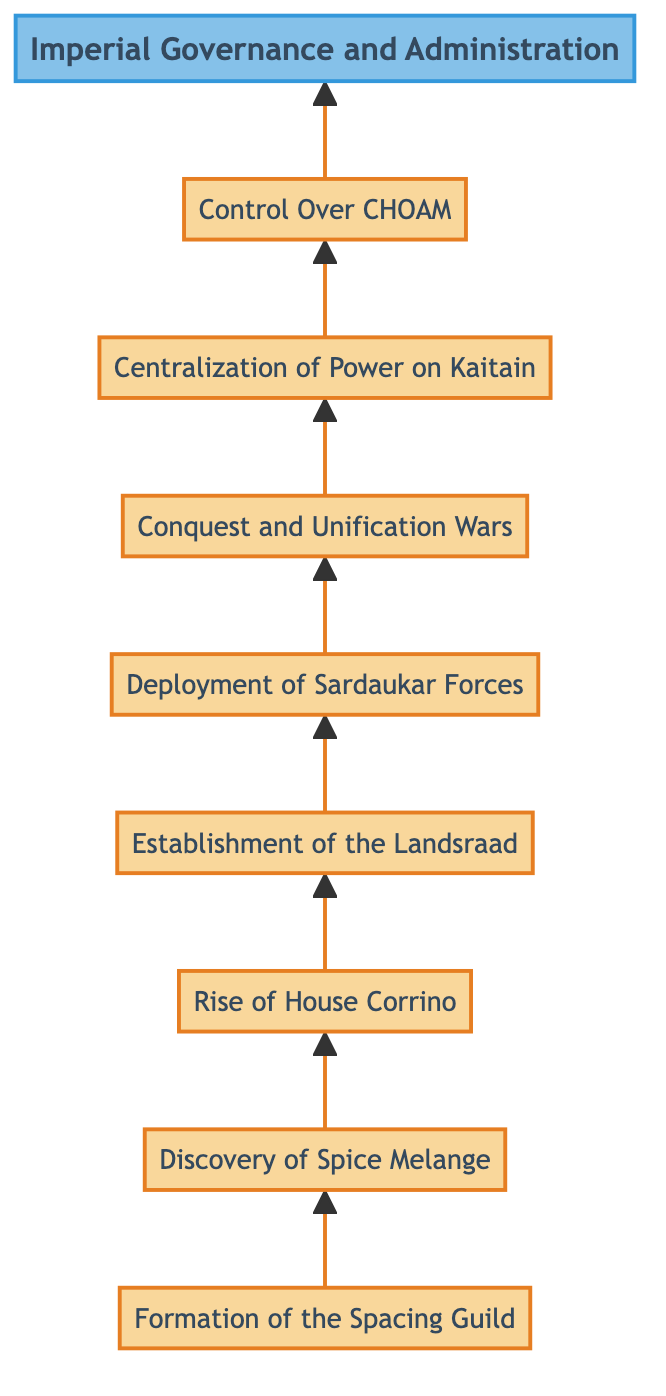What is the topmost node in the diagram? The topmost node in the diagram is "Imperial Governance and Administration," as it is the final point in the flowchart and is positioned at the top.
Answer: Imperial Governance and Administration How many nodes are present in the diagram? There are a total of nine nodes represented in the diagram, each corresponding to a significant event in the rise of the Galactic Empire.
Answer: 9 Which node follows the "Deployment of Sardaukar Forces"? The node that directly follows "Deployment of Sardaukar Forces" is "Conquest and Unification Wars," indicating the action resulting from the deployment of these elite troops.
Answer: Conquest and Unification Wars What event directly led to the "Rise of House Corrino"? The event that directly led to the "Rise of House Corrino" is the "Discovery of Spice Melange," as control over this valuable resource played a crucial role in their ascendancy.
Answer: Discovery of Spice Melange What is the relationship between "Establishment of the Landsraad" and "Centralization of Power on Kaitain"? "Establishment of the Landsraad" is a preceding event that contributes to the "Centralization of Power on Kaitain," as it facilitates political decision-making that consolidates power.
Answer: Establishment of the Landsraad What is the initial event that kickstarts the diagram's flow? The initial event that kickstarts the diagram is the "Formation of the Spacing Guild," which serves as the foundational step for the subsequent events.
Answer: Formation of the Spacing Guild How does "Control Over CHOAM" relate to "Imperial Governance and Administration"? "Control Over CHOAM" directly precedes "Imperial Governance and Administration," indicating that economic control plays a critical role in effective governance and administration of the empire.
Answer: Control Over CHOAM What type of flow is represented in the diagram? The diagram represents a bottom-to-top flow, where the progression of historical events leads to the ultimate establishment of governance at the top.
Answer: Bottom-to-top What significant military force is established to maintain control? The significant military force established to maintain control is the "Sardaukar," which are elite soldiers loyal to House Corrino used to suppress opposition.
Answer: Sardaukar 